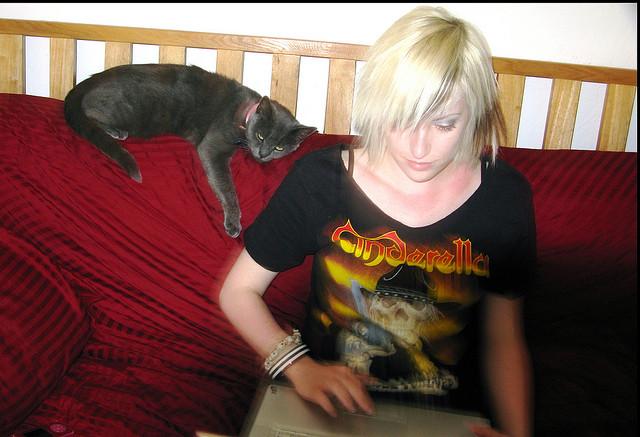What color is the couch cover?
Write a very short answer. Red. Is this kid wearing a band shirt?
Concise answer only. Yes. How old is cat?
Short answer required. 2 years. 